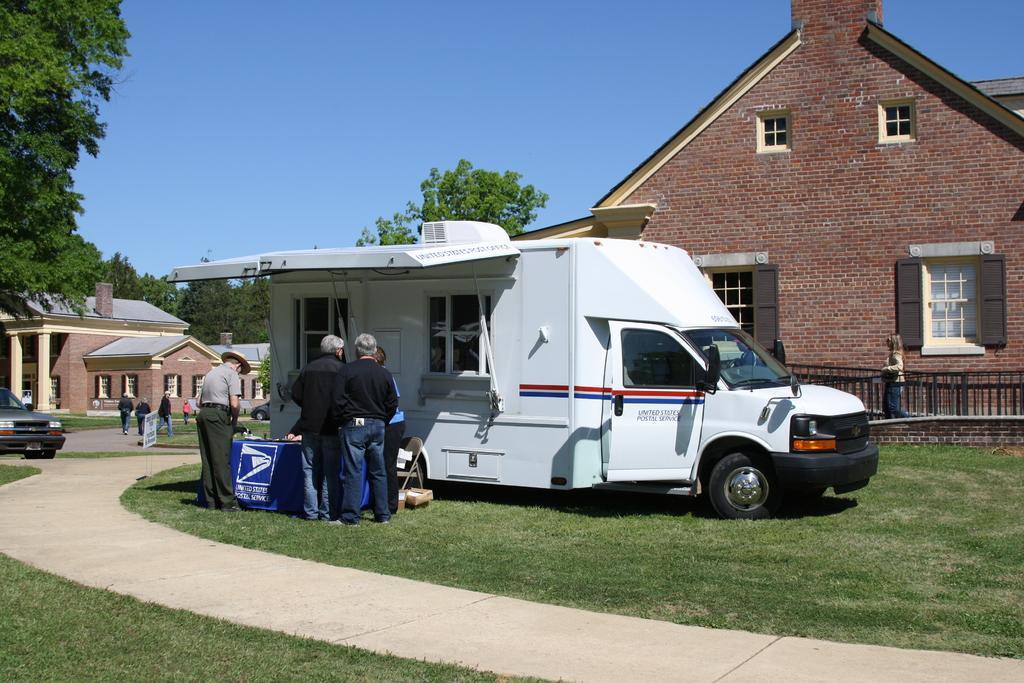Could you give a brief overview of what you see in this image? Here in this picture we can see a truck present on the ground, which is fully covered with grass over there and we can also see people standing near the truck as we can see a table present over there and we can also see houses present over there and we can see trees present all over there and we can also see a car present on the left side over there. 